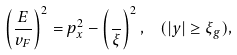<formula> <loc_0><loc_0><loc_500><loc_500>\left ( \frac { E } { v _ { F } } \right ) ^ { 2 } = p _ { x } ^ { 2 } - \left ( \frac { } { \xi } \right ) ^ { 2 } , \ \ ( | y | \geq \xi _ { g } ) ,</formula> 